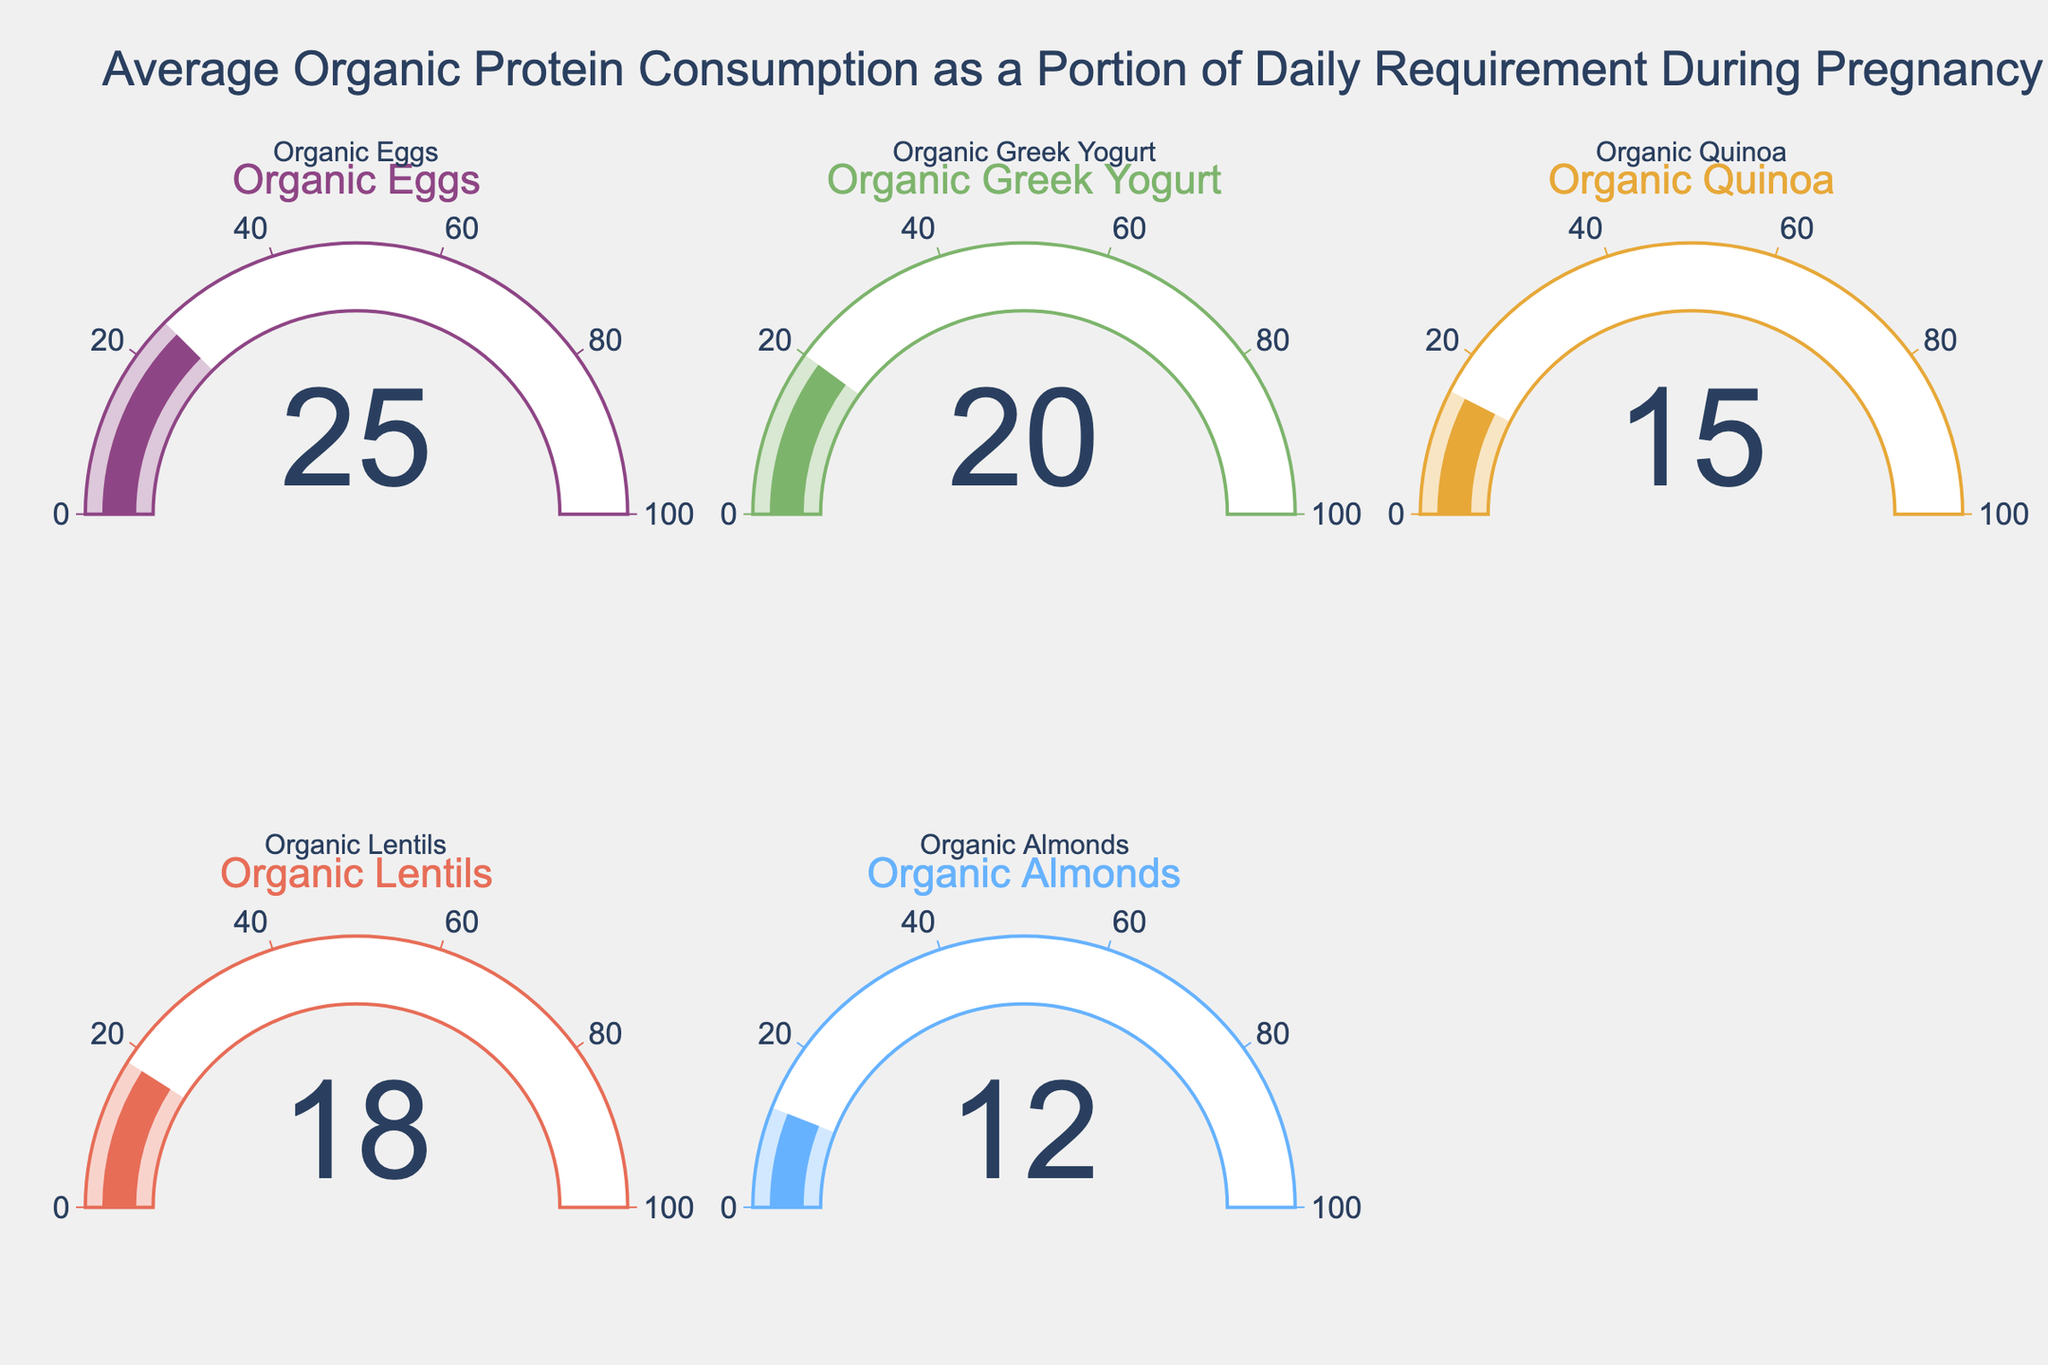What is the title of the figure? The title is located at the top of the figure. It summarizes the overall focus of the graph.
Answer: Average Organic Protein Consumption as a Portion of Daily Requirement During Pregnancy How many protein sources are displayed in the figure? By counting the number of gauges present in the figure, we can determine the number of protein sources.
Answer: 5 Which protein source contributes the highest percentage to the daily protein requirement? By examining the values displayed in each gauge, we identify the highest value.
Answer: Organic Eggs What is the combined percentage contribution of Organic Eggs and Organic Greek Yogurt to the daily protein requirement? Add the percentage values for Organic Eggs (25%) and Organic Greek Yogurt (20%). 25 + 20 = 45
Answer: 45 How much more percentage does Organic Eggs contribute to the daily protein requirement compared to Organic Almonds? Subtract the percentage value of Organic Almonds (12%) from Organic Eggs (25%). 25 - 12 = 13
Answer: 13 Which protein sources contribute less than 20% to the daily protein requirement? By identifying the gauges with values less than 20%, we find the relevant protein sources.
Answer: Organic Quinoa, Organic Lentils, Organic Almonds What is the average percentage contribution of all the protein sources? Sum all the percentage values and divide by the number of protein sources: (25 + 20 + 15 + 18 + 12) / 5 = 90 / 5 = 18
Answer: 18 Is the percentage contribution of Organic Lentils greater than that of Organic Quinoa? Compare the values of Organic Lentils (18%) and Organic Quinoa (15%).
Answer: Yes What is the difference in percentage contribution between the highest and lowest contributing protein sources? Subtract the lowest value (Organic Almonds, 12%) from the highest value (Organic Eggs, 25%). 25 - 12 = 13
Answer: 13 By what percentage does Organic Greek Yogurt’s contribution exceed that of Organic Almonds? Subtract the percentage value of Organic Almonds (12%) from Organic Greek Yogurt (20%). 20 - 12 = 8
Answer: 8 